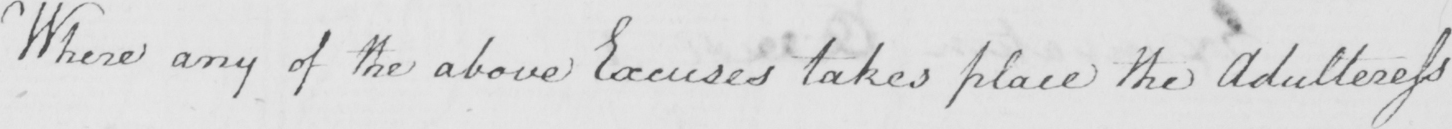What text is written in this handwritten line? Where any of the above Excuses takes place the Adulteress 